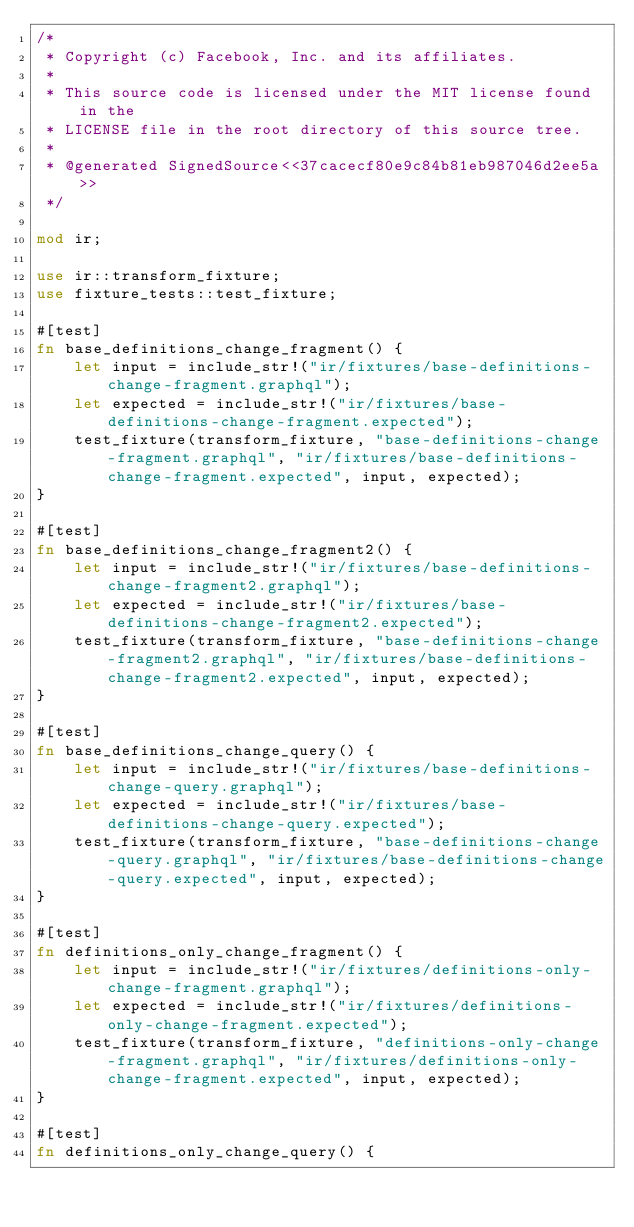Convert code to text. <code><loc_0><loc_0><loc_500><loc_500><_Rust_>/*
 * Copyright (c) Facebook, Inc. and its affiliates.
 *
 * This source code is licensed under the MIT license found in the
 * LICENSE file in the root directory of this source tree.
 *
 * @generated SignedSource<<37cacecf80e9c84b81eb987046d2ee5a>>
 */

mod ir;

use ir::transform_fixture;
use fixture_tests::test_fixture;

#[test]
fn base_definitions_change_fragment() {
    let input = include_str!("ir/fixtures/base-definitions-change-fragment.graphql");
    let expected = include_str!("ir/fixtures/base-definitions-change-fragment.expected");
    test_fixture(transform_fixture, "base-definitions-change-fragment.graphql", "ir/fixtures/base-definitions-change-fragment.expected", input, expected);
}

#[test]
fn base_definitions_change_fragment2() {
    let input = include_str!("ir/fixtures/base-definitions-change-fragment2.graphql");
    let expected = include_str!("ir/fixtures/base-definitions-change-fragment2.expected");
    test_fixture(transform_fixture, "base-definitions-change-fragment2.graphql", "ir/fixtures/base-definitions-change-fragment2.expected", input, expected);
}

#[test]
fn base_definitions_change_query() {
    let input = include_str!("ir/fixtures/base-definitions-change-query.graphql");
    let expected = include_str!("ir/fixtures/base-definitions-change-query.expected");
    test_fixture(transform_fixture, "base-definitions-change-query.graphql", "ir/fixtures/base-definitions-change-query.expected", input, expected);
}

#[test]
fn definitions_only_change_fragment() {
    let input = include_str!("ir/fixtures/definitions-only-change-fragment.graphql");
    let expected = include_str!("ir/fixtures/definitions-only-change-fragment.expected");
    test_fixture(transform_fixture, "definitions-only-change-fragment.graphql", "ir/fixtures/definitions-only-change-fragment.expected", input, expected);
}

#[test]
fn definitions_only_change_query() {</code> 